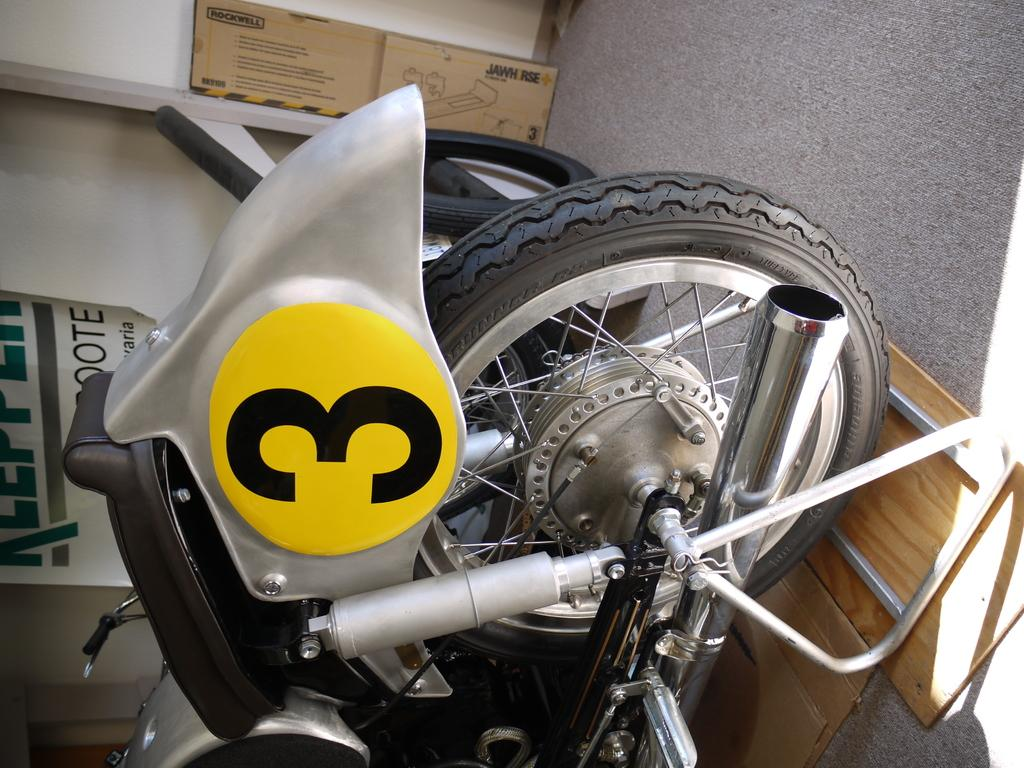<image>
Provide a brief description of the given image. A motorcycle has a big number 3 in a yellow circle on it. 